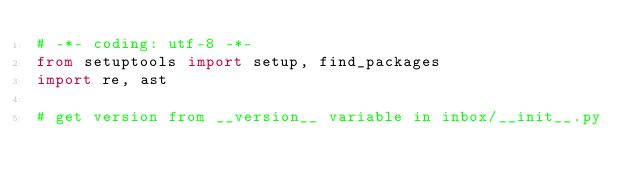<code> <loc_0><loc_0><loc_500><loc_500><_Python_># -*- coding: utf-8 -*-
from setuptools import setup, find_packages
import re, ast

# get version from __version__ variable in inbox/__init__.py</code> 